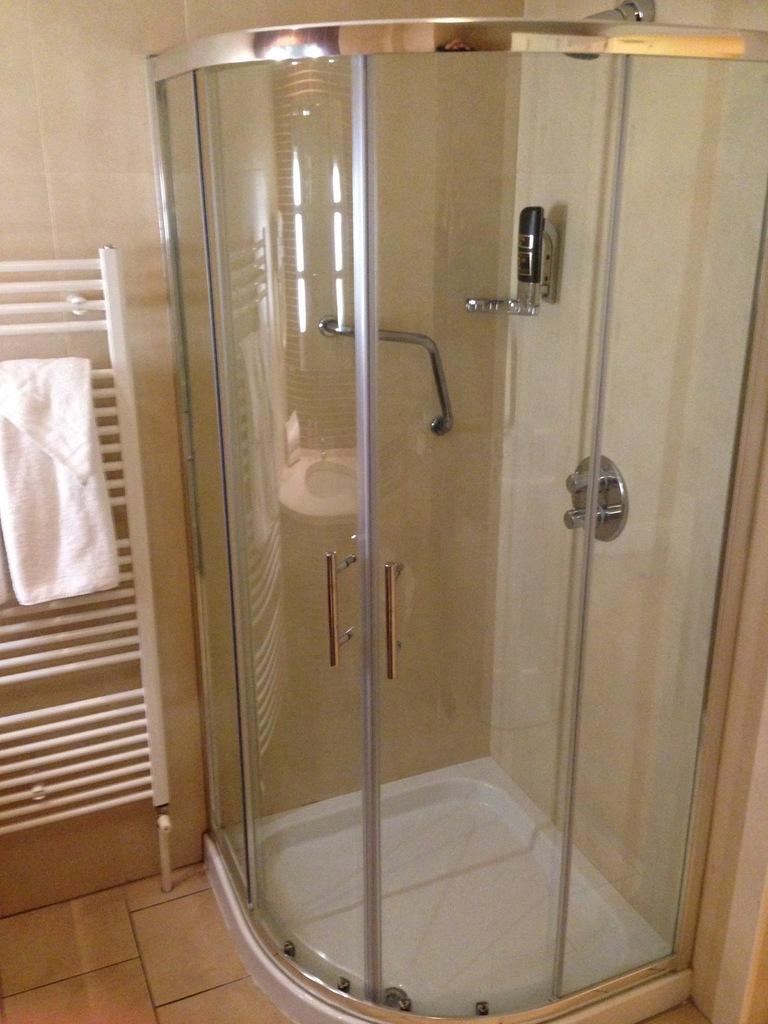Please provide a concise description of this image. In the foreground of this image, there is a shower enclosure with glass doors and tapes inside it. On the left, there is a towel on a stand. Behind it, there is a wall. At the bottom, there is the floor. 